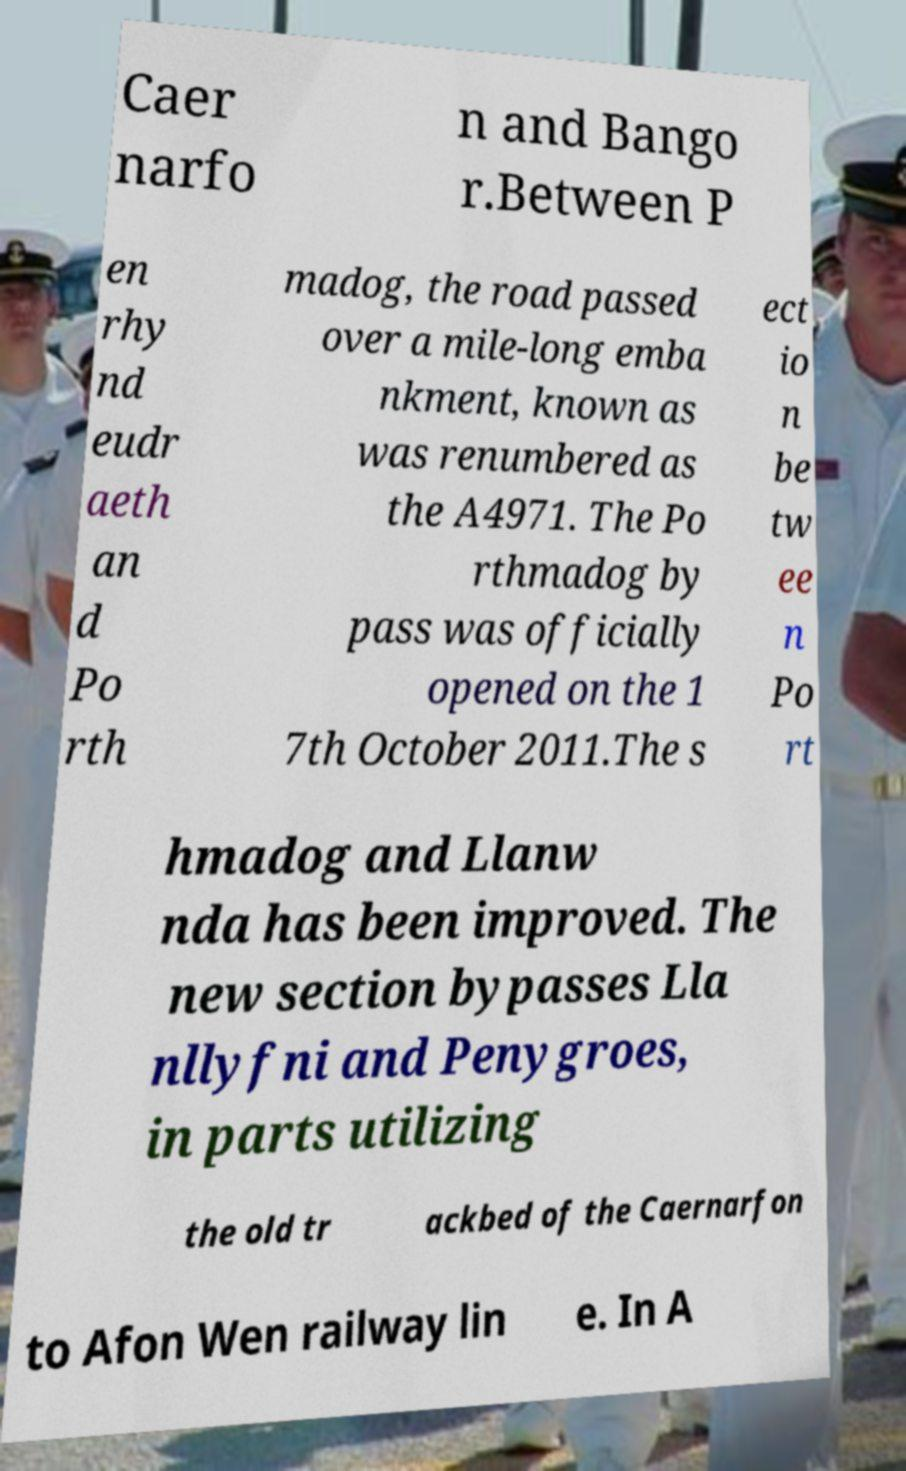Can you read and provide the text displayed in the image?This photo seems to have some interesting text. Can you extract and type it out for me? Caer narfo n and Bango r.Between P en rhy nd eudr aeth an d Po rth madog, the road passed over a mile-long emba nkment, known as was renumbered as the A4971. The Po rthmadog by pass was officially opened on the 1 7th October 2011.The s ect io n be tw ee n Po rt hmadog and Llanw nda has been improved. The new section bypasses Lla nllyfni and Penygroes, in parts utilizing the old tr ackbed of the Caernarfon to Afon Wen railway lin e. In A 